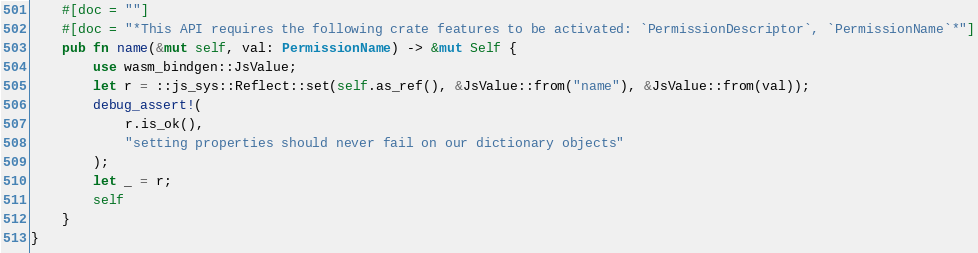Convert code to text. <code><loc_0><loc_0><loc_500><loc_500><_Rust_>    #[doc = ""]
    #[doc = "*This API requires the following crate features to be activated: `PermissionDescriptor`, `PermissionName`*"]
    pub fn name(&mut self, val: PermissionName) -> &mut Self {
        use wasm_bindgen::JsValue;
        let r = ::js_sys::Reflect::set(self.as_ref(), &JsValue::from("name"), &JsValue::from(val));
        debug_assert!(
            r.is_ok(),
            "setting properties should never fail on our dictionary objects"
        );
        let _ = r;
        self
    }
}
</code> 